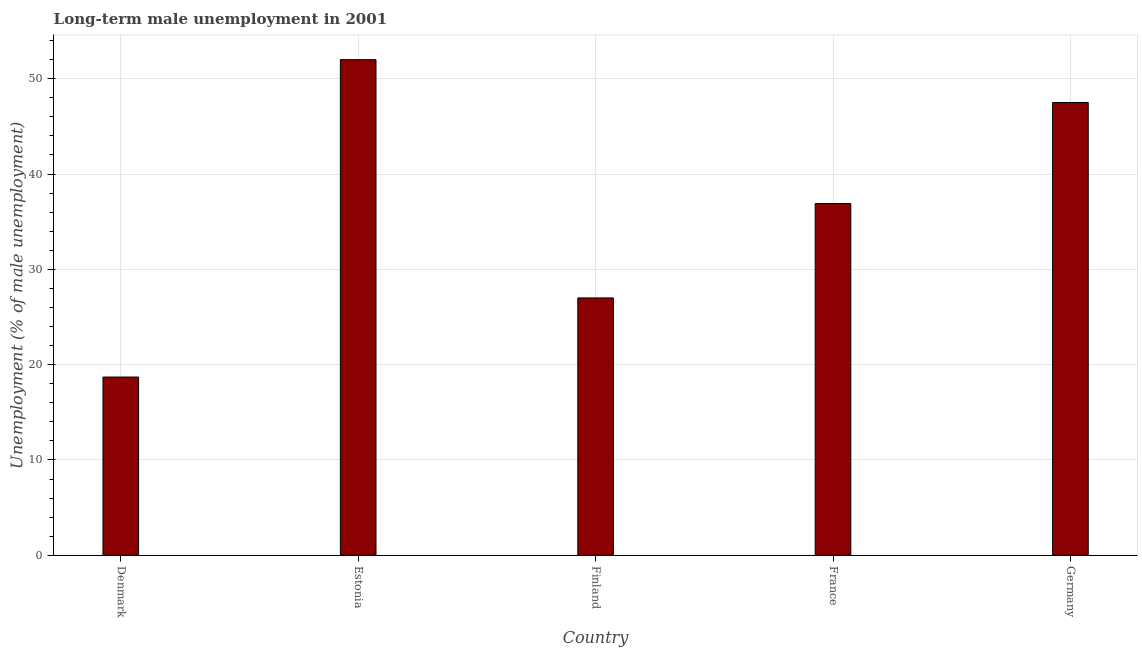Does the graph contain any zero values?
Your response must be concise. No. What is the title of the graph?
Offer a very short reply. Long-term male unemployment in 2001. What is the label or title of the Y-axis?
Your answer should be compact. Unemployment (% of male unemployment). What is the long-term male unemployment in France?
Provide a short and direct response. 36.9. Across all countries, what is the minimum long-term male unemployment?
Ensure brevity in your answer.  18.7. In which country was the long-term male unemployment maximum?
Your answer should be compact. Estonia. In which country was the long-term male unemployment minimum?
Ensure brevity in your answer.  Denmark. What is the sum of the long-term male unemployment?
Provide a short and direct response. 182.1. What is the average long-term male unemployment per country?
Provide a short and direct response. 36.42. What is the median long-term male unemployment?
Provide a short and direct response. 36.9. In how many countries, is the long-term male unemployment greater than 14 %?
Provide a succinct answer. 5. What is the ratio of the long-term male unemployment in Denmark to that in Estonia?
Offer a very short reply. 0.36. Is the difference between the long-term male unemployment in Estonia and France greater than the difference between any two countries?
Your response must be concise. No. Is the sum of the long-term male unemployment in Estonia and France greater than the maximum long-term male unemployment across all countries?
Offer a very short reply. Yes. What is the difference between the highest and the lowest long-term male unemployment?
Your answer should be very brief. 33.3. In how many countries, is the long-term male unemployment greater than the average long-term male unemployment taken over all countries?
Keep it short and to the point. 3. How many bars are there?
Your response must be concise. 5. What is the difference between two consecutive major ticks on the Y-axis?
Your answer should be compact. 10. Are the values on the major ticks of Y-axis written in scientific E-notation?
Give a very brief answer. No. What is the Unemployment (% of male unemployment) of Denmark?
Offer a very short reply. 18.7. What is the Unemployment (% of male unemployment) in Finland?
Your response must be concise. 27. What is the Unemployment (% of male unemployment) in France?
Your answer should be compact. 36.9. What is the Unemployment (% of male unemployment) in Germany?
Ensure brevity in your answer.  47.5. What is the difference between the Unemployment (% of male unemployment) in Denmark and Estonia?
Give a very brief answer. -33.3. What is the difference between the Unemployment (% of male unemployment) in Denmark and France?
Keep it short and to the point. -18.2. What is the difference between the Unemployment (% of male unemployment) in Denmark and Germany?
Give a very brief answer. -28.8. What is the difference between the Unemployment (% of male unemployment) in Estonia and Finland?
Your response must be concise. 25. What is the difference between the Unemployment (% of male unemployment) in Estonia and France?
Offer a terse response. 15.1. What is the difference between the Unemployment (% of male unemployment) in Finland and Germany?
Ensure brevity in your answer.  -20.5. What is the ratio of the Unemployment (% of male unemployment) in Denmark to that in Estonia?
Your answer should be very brief. 0.36. What is the ratio of the Unemployment (% of male unemployment) in Denmark to that in Finland?
Offer a terse response. 0.69. What is the ratio of the Unemployment (% of male unemployment) in Denmark to that in France?
Make the answer very short. 0.51. What is the ratio of the Unemployment (% of male unemployment) in Denmark to that in Germany?
Keep it short and to the point. 0.39. What is the ratio of the Unemployment (% of male unemployment) in Estonia to that in Finland?
Your answer should be very brief. 1.93. What is the ratio of the Unemployment (% of male unemployment) in Estonia to that in France?
Your answer should be very brief. 1.41. What is the ratio of the Unemployment (% of male unemployment) in Estonia to that in Germany?
Ensure brevity in your answer.  1.09. What is the ratio of the Unemployment (% of male unemployment) in Finland to that in France?
Offer a very short reply. 0.73. What is the ratio of the Unemployment (% of male unemployment) in Finland to that in Germany?
Offer a terse response. 0.57. What is the ratio of the Unemployment (% of male unemployment) in France to that in Germany?
Make the answer very short. 0.78. 